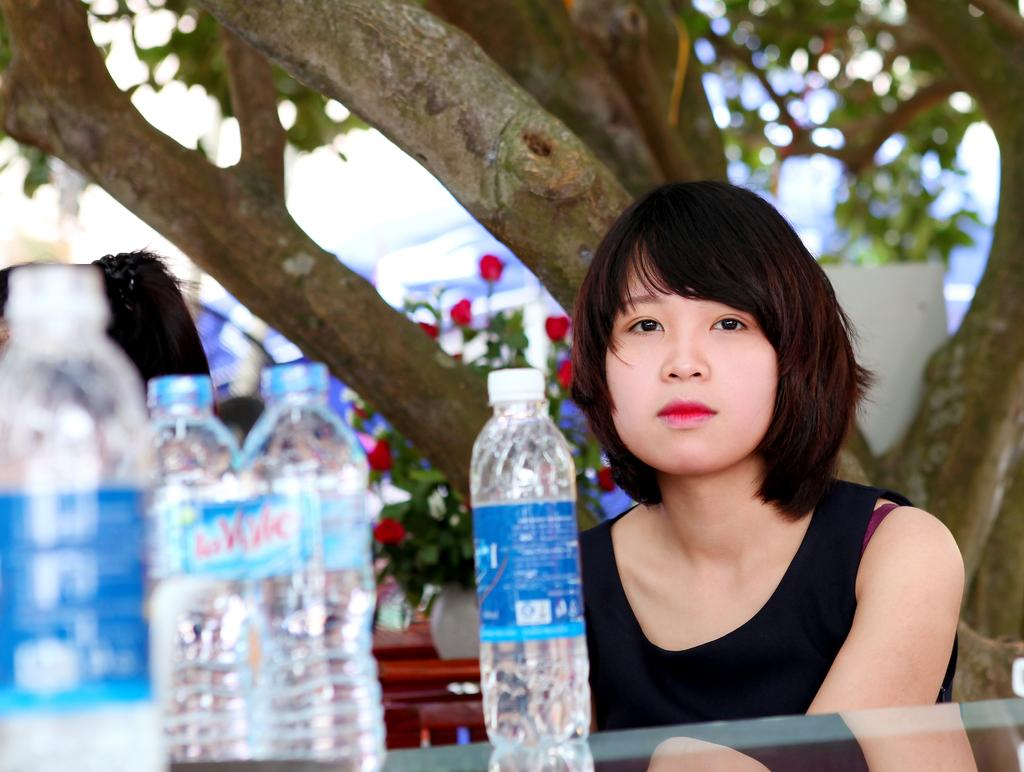What is present in the image besides the woman? There is a tree and bottles in front of the woman. Can you describe the woman in the image? The image shows a woman. What is the woman holding or interacting with in the image? The woman is in front of bottles. What type of floor can be seen under the woman in the image? There is no floor visible in the image; it appears to be an outdoor setting with grass or ground. What kind of pear is the woman holding in the image? There is no pear present in the image. 